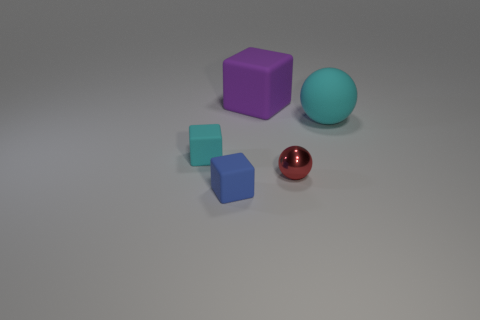What material is the purple block that is the same size as the cyan sphere?
Keep it short and to the point. Rubber. How many cyan objects are either big blocks or rubber spheres?
Keep it short and to the point. 1. The object that is both in front of the large purple thing and behind the cyan block is what color?
Provide a short and direct response. Cyan. Does the ball that is to the left of the cyan rubber ball have the same material as the small cyan cube to the left of the cyan sphere?
Offer a very short reply. No. Is the number of tiny blue rubber cubes in front of the purple thing greater than the number of big matte blocks in front of the tiny cyan rubber cube?
Provide a short and direct response. Yes. There is a cyan thing that is the same size as the metallic ball; what is its shape?
Make the answer very short. Cube. What number of objects are either yellow balls or matte objects to the left of the matte sphere?
Keep it short and to the point. 3. What number of rubber objects are on the left side of the large cube?
Offer a terse response. 2. The large block that is made of the same material as the small cyan cube is what color?
Offer a very short reply. Purple. How many matte things are either red balls or big things?
Make the answer very short. 2. 